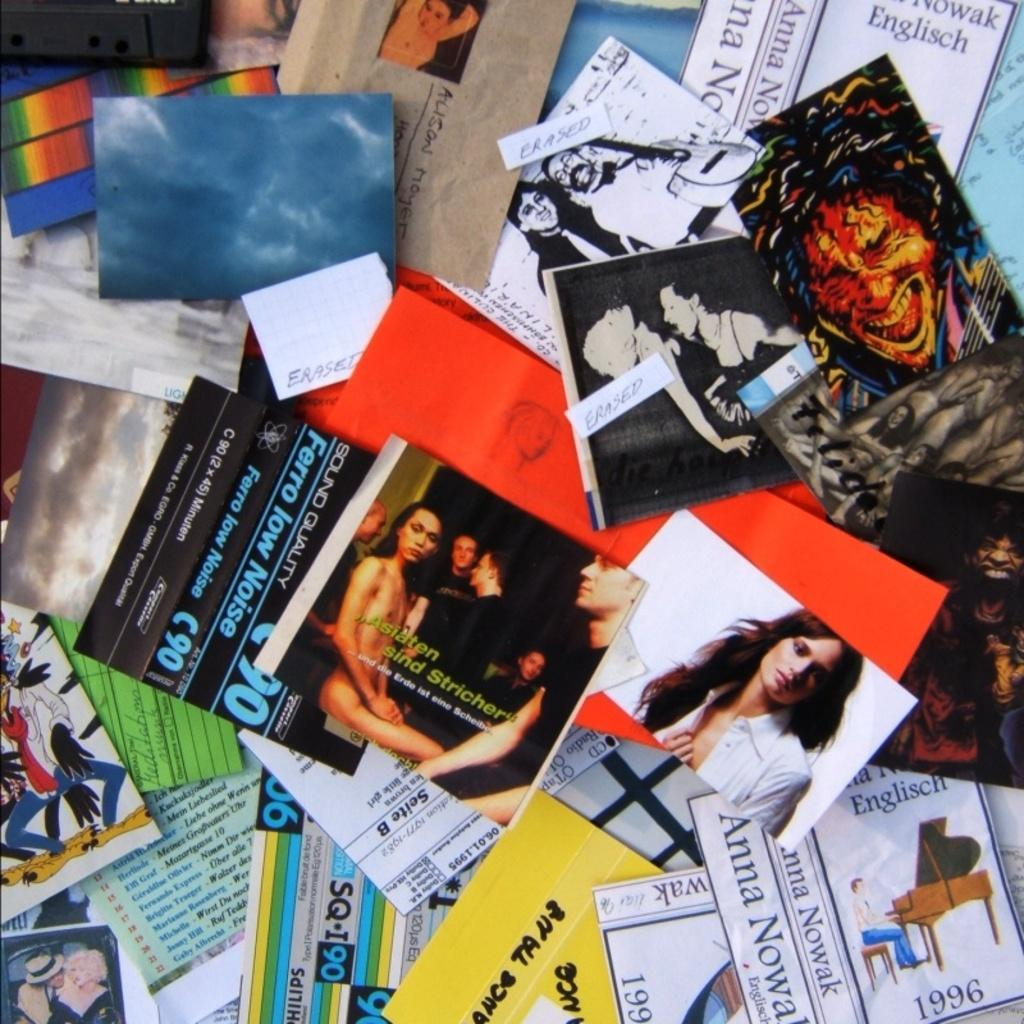<image>
Share a concise interpretation of the image provided. Several handbills with german sayings are scattered about on a table. 